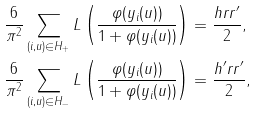Convert formula to latex. <formula><loc_0><loc_0><loc_500><loc_500>\frac { 6 } { \pi ^ { 2 } } \sum _ { ( i , u ) \in H _ { + } } L \left ( \frac { \varphi ( y _ { i } ( u ) ) } { 1 + \varphi ( y _ { i } ( u ) ) } \right ) & = \frac { h r r ^ { \prime } } { 2 } , \\ \frac { 6 } { \pi ^ { 2 } } \sum _ { ( i , u ) \in H _ { - } } L \left ( \frac { \varphi ( y _ { i } ( u ) ) } { 1 + \varphi ( y _ { i } ( u ) ) } \right ) & = \frac { h ^ { \prime } r r ^ { \prime } } { 2 } ,</formula> 